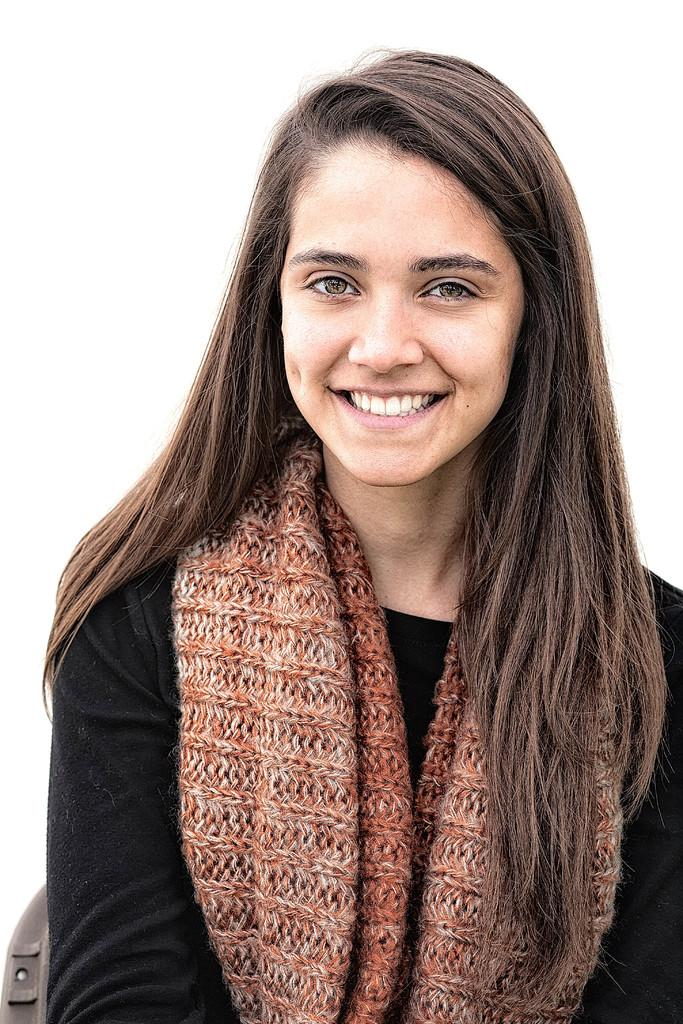What is the main subject of the image? There is a close-up picture of a woman in the image. What can be observed about the woman's attire? The woman is wearing clothes. What is the woman's facial expression in the image? The woman is smiling. What color is the background of the image? The background of the image is white. What type of cabbage is the woman holding in the image? There is no cabbage present in the image; it features a close-up picture of a woman. Can you tell me the route the woman took to get to the location of the image? The image does not provide information about the woman's route or how she arrived at the location. 